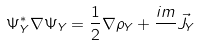<formula> <loc_0><loc_0><loc_500><loc_500>\Psi _ { Y } ^ { * } \nabla \Psi _ { Y } = \frac { 1 } { 2 } \nabla \rho _ { Y } + \frac { i m } { } \vec { J } _ { Y }</formula> 